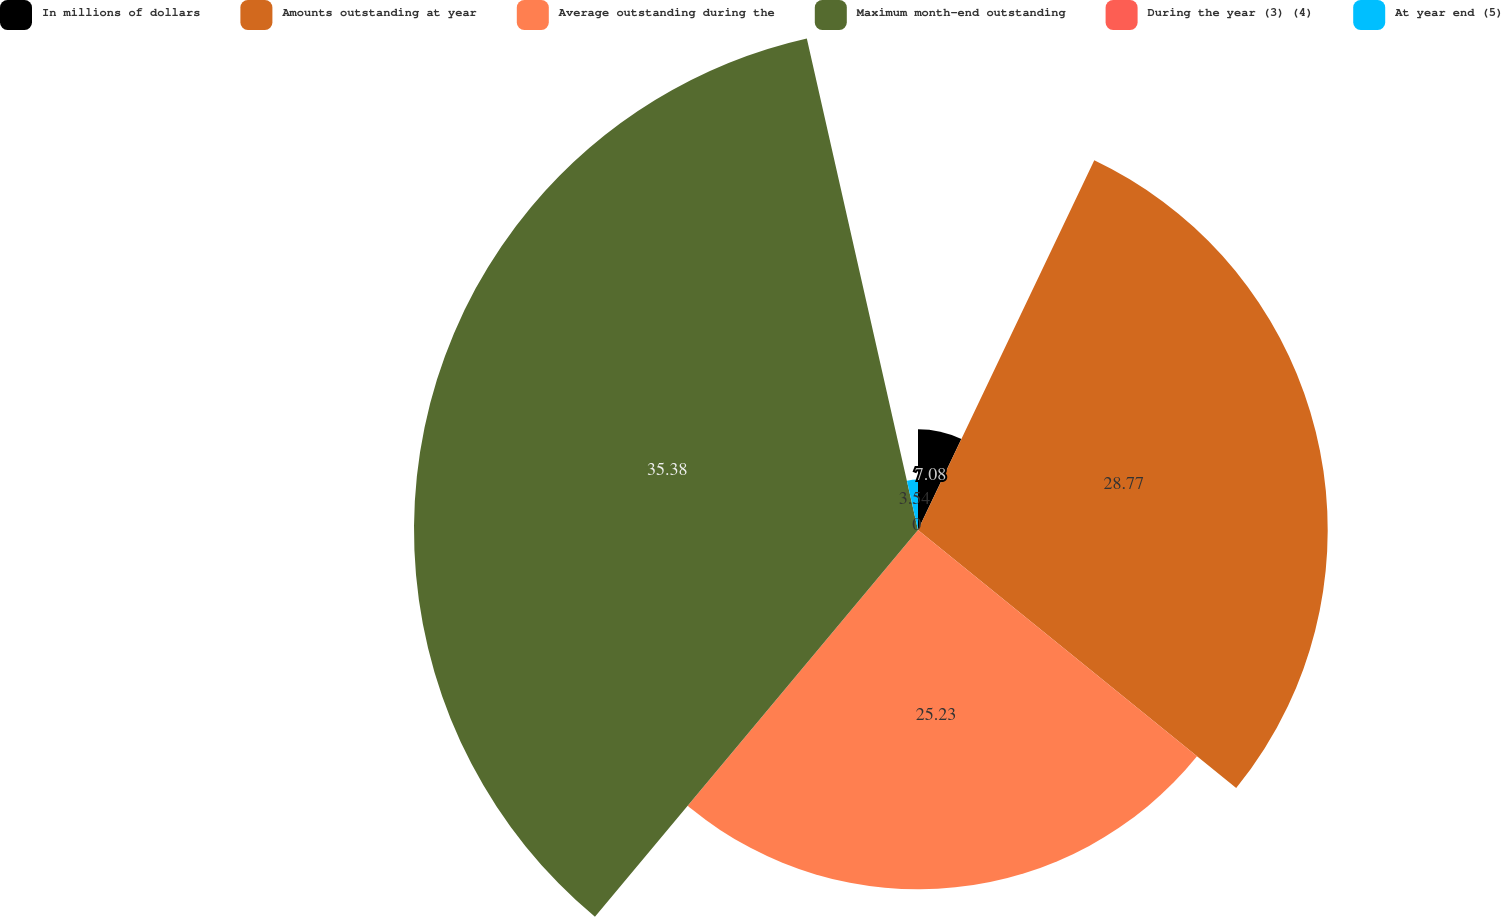<chart> <loc_0><loc_0><loc_500><loc_500><pie_chart><fcel>In millions of dollars<fcel>Amounts outstanding at year<fcel>Average outstanding during the<fcel>Maximum month-end outstanding<fcel>During the year (3) (4)<fcel>At year end (5)<nl><fcel>7.08%<fcel>28.77%<fcel>25.23%<fcel>35.39%<fcel>0.0%<fcel>3.54%<nl></chart> 